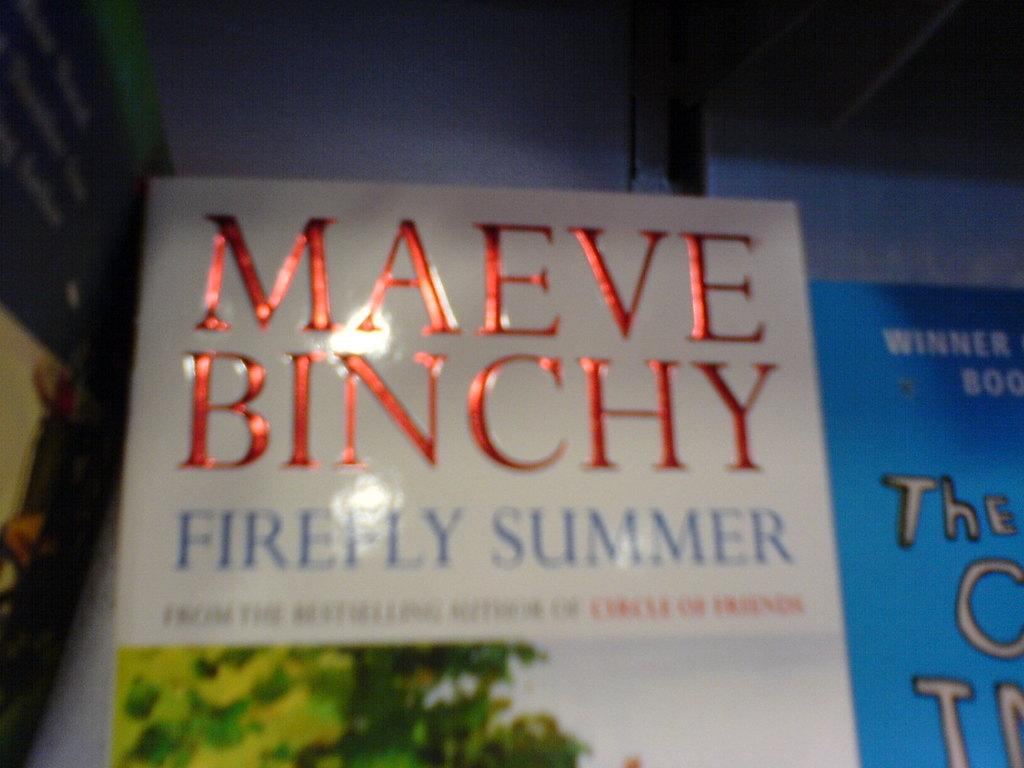<image>
Offer a succinct explanation of the picture presented. A book titled Firefly Summer shows the authors name in red foiled lettering. 